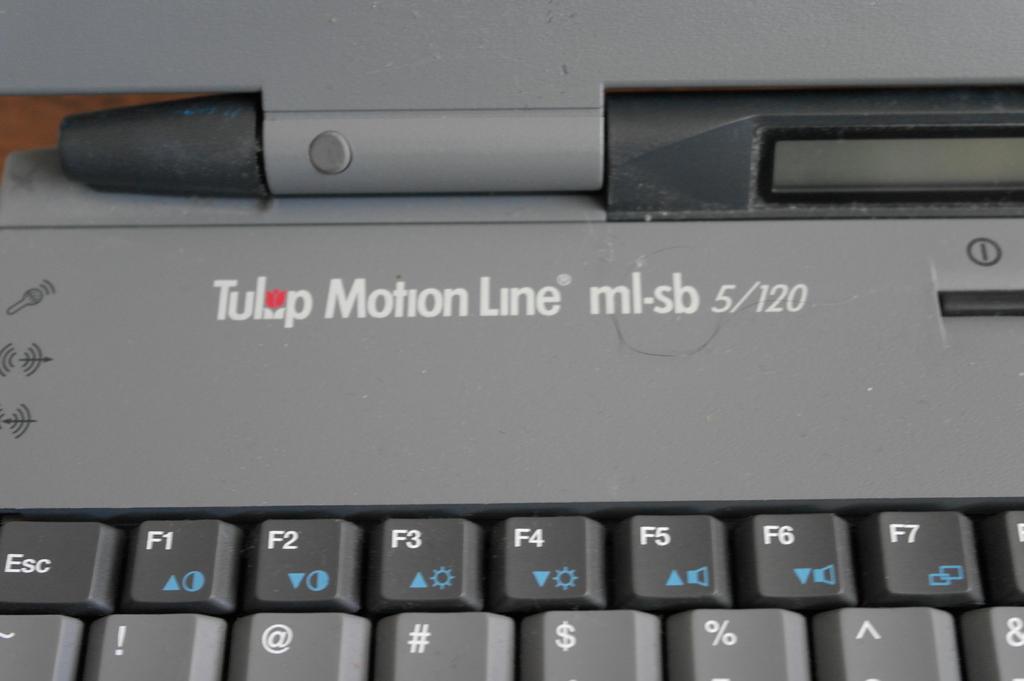What is this brand of computer?
Make the answer very short. Tulip motion line. Computer brand apple, hp?
Make the answer very short. Tulip. 